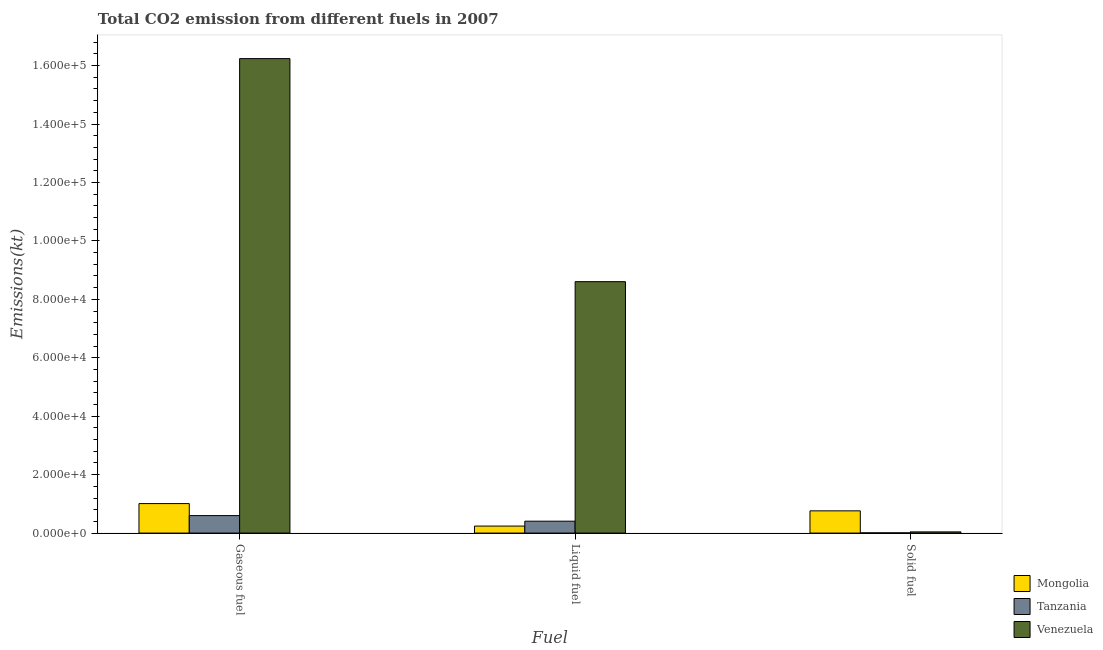How many different coloured bars are there?
Your answer should be compact. 3. How many groups of bars are there?
Offer a very short reply. 3. Are the number of bars per tick equal to the number of legend labels?
Give a very brief answer. Yes. How many bars are there on the 3rd tick from the right?
Provide a succinct answer. 3. What is the label of the 1st group of bars from the left?
Give a very brief answer. Gaseous fuel. What is the amount of co2 emissions from solid fuel in Mongolia?
Your answer should be compact. 7605.36. Across all countries, what is the maximum amount of co2 emissions from liquid fuel?
Your answer should be very brief. 8.60e+04. Across all countries, what is the minimum amount of co2 emissions from solid fuel?
Offer a very short reply. 73.34. In which country was the amount of co2 emissions from liquid fuel maximum?
Your answer should be very brief. Venezuela. In which country was the amount of co2 emissions from liquid fuel minimum?
Your response must be concise. Mongolia. What is the total amount of co2 emissions from liquid fuel in the graph?
Your answer should be very brief. 9.25e+04. What is the difference between the amount of co2 emissions from solid fuel in Tanzania and that in Venezuela?
Offer a terse response. -330.03. What is the difference between the amount of co2 emissions from liquid fuel in Mongolia and the amount of co2 emissions from gaseous fuel in Tanzania?
Offer a terse response. -3582.66. What is the average amount of co2 emissions from liquid fuel per country?
Make the answer very short. 3.08e+04. What is the difference between the amount of co2 emissions from gaseous fuel and amount of co2 emissions from liquid fuel in Venezuela?
Keep it short and to the point. 7.63e+04. In how many countries, is the amount of co2 emissions from gaseous fuel greater than 124000 kt?
Your answer should be compact. 1. What is the ratio of the amount of co2 emissions from solid fuel in Tanzania to that in Venezuela?
Offer a very short reply. 0.18. Is the amount of co2 emissions from gaseous fuel in Venezuela less than that in Tanzania?
Provide a short and direct response. No. What is the difference between the highest and the second highest amount of co2 emissions from solid fuel?
Your answer should be compact. 7201.99. What is the difference between the highest and the lowest amount of co2 emissions from solid fuel?
Keep it short and to the point. 7532.02. In how many countries, is the amount of co2 emissions from liquid fuel greater than the average amount of co2 emissions from liquid fuel taken over all countries?
Offer a terse response. 1. Is the sum of the amount of co2 emissions from gaseous fuel in Venezuela and Tanzania greater than the maximum amount of co2 emissions from solid fuel across all countries?
Ensure brevity in your answer.  Yes. What does the 1st bar from the left in Liquid fuel represents?
Provide a succinct answer. Mongolia. What does the 3rd bar from the right in Liquid fuel represents?
Offer a very short reply. Mongolia. How many bars are there?
Provide a succinct answer. 9. Are all the bars in the graph horizontal?
Keep it short and to the point. No. Are the values on the major ticks of Y-axis written in scientific E-notation?
Make the answer very short. Yes. Does the graph contain any zero values?
Provide a short and direct response. No. What is the title of the graph?
Provide a succinct answer. Total CO2 emission from different fuels in 2007. Does "Malaysia" appear as one of the legend labels in the graph?
Provide a short and direct response. No. What is the label or title of the X-axis?
Your answer should be very brief. Fuel. What is the label or title of the Y-axis?
Make the answer very short. Emissions(kt). What is the Emissions(kt) of Mongolia in Gaseous fuel?
Offer a very short reply. 1.01e+04. What is the Emissions(kt) in Tanzania in Gaseous fuel?
Offer a terse response. 5980.88. What is the Emissions(kt) in Venezuela in Gaseous fuel?
Offer a terse response. 1.62e+05. What is the Emissions(kt) of Mongolia in Liquid fuel?
Provide a succinct answer. 2398.22. What is the Emissions(kt) of Tanzania in Liquid fuel?
Give a very brief answer. 4070.37. What is the Emissions(kt) in Venezuela in Liquid fuel?
Offer a terse response. 8.60e+04. What is the Emissions(kt) of Mongolia in Solid fuel?
Your response must be concise. 7605.36. What is the Emissions(kt) of Tanzania in Solid fuel?
Keep it short and to the point. 73.34. What is the Emissions(kt) in Venezuela in Solid fuel?
Offer a very short reply. 403.37. Across all Fuel, what is the maximum Emissions(kt) of Mongolia?
Provide a short and direct response. 1.01e+04. Across all Fuel, what is the maximum Emissions(kt) in Tanzania?
Keep it short and to the point. 5980.88. Across all Fuel, what is the maximum Emissions(kt) in Venezuela?
Ensure brevity in your answer.  1.62e+05. Across all Fuel, what is the minimum Emissions(kt) in Mongolia?
Offer a terse response. 2398.22. Across all Fuel, what is the minimum Emissions(kt) in Tanzania?
Your response must be concise. 73.34. Across all Fuel, what is the minimum Emissions(kt) in Venezuela?
Your answer should be very brief. 403.37. What is the total Emissions(kt) of Mongolia in the graph?
Offer a terse response. 2.01e+04. What is the total Emissions(kt) in Tanzania in the graph?
Provide a short and direct response. 1.01e+04. What is the total Emissions(kt) of Venezuela in the graph?
Ensure brevity in your answer.  2.49e+05. What is the difference between the Emissions(kt) of Mongolia in Gaseous fuel and that in Liquid fuel?
Keep it short and to the point. 7693.37. What is the difference between the Emissions(kt) in Tanzania in Gaseous fuel and that in Liquid fuel?
Make the answer very short. 1910.51. What is the difference between the Emissions(kt) of Venezuela in Gaseous fuel and that in Liquid fuel?
Your answer should be very brief. 7.63e+04. What is the difference between the Emissions(kt) of Mongolia in Gaseous fuel and that in Solid fuel?
Ensure brevity in your answer.  2486.23. What is the difference between the Emissions(kt) in Tanzania in Gaseous fuel and that in Solid fuel?
Your response must be concise. 5907.54. What is the difference between the Emissions(kt) of Venezuela in Gaseous fuel and that in Solid fuel?
Provide a succinct answer. 1.62e+05. What is the difference between the Emissions(kt) in Mongolia in Liquid fuel and that in Solid fuel?
Ensure brevity in your answer.  -5207.14. What is the difference between the Emissions(kt) of Tanzania in Liquid fuel and that in Solid fuel?
Keep it short and to the point. 3997.03. What is the difference between the Emissions(kt) of Venezuela in Liquid fuel and that in Solid fuel?
Make the answer very short. 8.56e+04. What is the difference between the Emissions(kt) in Mongolia in Gaseous fuel and the Emissions(kt) in Tanzania in Liquid fuel?
Offer a terse response. 6021.21. What is the difference between the Emissions(kt) in Mongolia in Gaseous fuel and the Emissions(kt) in Venezuela in Liquid fuel?
Your answer should be compact. -7.60e+04. What is the difference between the Emissions(kt) in Tanzania in Gaseous fuel and the Emissions(kt) in Venezuela in Liquid fuel?
Offer a terse response. -8.01e+04. What is the difference between the Emissions(kt) of Mongolia in Gaseous fuel and the Emissions(kt) of Tanzania in Solid fuel?
Your answer should be very brief. 1.00e+04. What is the difference between the Emissions(kt) of Mongolia in Gaseous fuel and the Emissions(kt) of Venezuela in Solid fuel?
Keep it short and to the point. 9688.21. What is the difference between the Emissions(kt) of Tanzania in Gaseous fuel and the Emissions(kt) of Venezuela in Solid fuel?
Your response must be concise. 5577.51. What is the difference between the Emissions(kt) of Mongolia in Liquid fuel and the Emissions(kt) of Tanzania in Solid fuel?
Provide a succinct answer. 2324.88. What is the difference between the Emissions(kt) in Mongolia in Liquid fuel and the Emissions(kt) in Venezuela in Solid fuel?
Offer a very short reply. 1994.85. What is the difference between the Emissions(kt) of Tanzania in Liquid fuel and the Emissions(kt) of Venezuela in Solid fuel?
Your answer should be compact. 3667. What is the average Emissions(kt) in Mongolia per Fuel?
Give a very brief answer. 6698.39. What is the average Emissions(kt) of Tanzania per Fuel?
Keep it short and to the point. 3374.86. What is the average Emissions(kt) in Venezuela per Fuel?
Your response must be concise. 8.29e+04. What is the difference between the Emissions(kt) of Mongolia and Emissions(kt) of Tanzania in Gaseous fuel?
Give a very brief answer. 4110.71. What is the difference between the Emissions(kt) in Mongolia and Emissions(kt) in Venezuela in Gaseous fuel?
Ensure brevity in your answer.  -1.52e+05. What is the difference between the Emissions(kt) in Tanzania and Emissions(kt) in Venezuela in Gaseous fuel?
Keep it short and to the point. -1.56e+05. What is the difference between the Emissions(kt) of Mongolia and Emissions(kt) of Tanzania in Liquid fuel?
Provide a short and direct response. -1672.15. What is the difference between the Emissions(kt) in Mongolia and Emissions(kt) in Venezuela in Liquid fuel?
Give a very brief answer. -8.36e+04. What is the difference between the Emissions(kt) of Tanzania and Emissions(kt) of Venezuela in Liquid fuel?
Offer a terse response. -8.20e+04. What is the difference between the Emissions(kt) in Mongolia and Emissions(kt) in Tanzania in Solid fuel?
Keep it short and to the point. 7532.02. What is the difference between the Emissions(kt) in Mongolia and Emissions(kt) in Venezuela in Solid fuel?
Offer a terse response. 7201.99. What is the difference between the Emissions(kt) of Tanzania and Emissions(kt) of Venezuela in Solid fuel?
Your response must be concise. -330.03. What is the ratio of the Emissions(kt) of Mongolia in Gaseous fuel to that in Liquid fuel?
Offer a terse response. 4.21. What is the ratio of the Emissions(kt) of Tanzania in Gaseous fuel to that in Liquid fuel?
Your answer should be compact. 1.47. What is the ratio of the Emissions(kt) in Venezuela in Gaseous fuel to that in Liquid fuel?
Ensure brevity in your answer.  1.89. What is the ratio of the Emissions(kt) in Mongolia in Gaseous fuel to that in Solid fuel?
Offer a very short reply. 1.33. What is the ratio of the Emissions(kt) in Tanzania in Gaseous fuel to that in Solid fuel?
Provide a succinct answer. 81.55. What is the ratio of the Emissions(kt) in Venezuela in Gaseous fuel to that in Solid fuel?
Your response must be concise. 402.57. What is the ratio of the Emissions(kt) of Mongolia in Liquid fuel to that in Solid fuel?
Offer a terse response. 0.32. What is the ratio of the Emissions(kt) of Tanzania in Liquid fuel to that in Solid fuel?
Make the answer very short. 55.5. What is the ratio of the Emissions(kt) in Venezuela in Liquid fuel to that in Solid fuel?
Give a very brief answer. 213.31. What is the difference between the highest and the second highest Emissions(kt) of Mongolia?
Your answer should be very brief. 2486.23. What is the difference between the highest and the second highest Emissions(kt) of Tanzania?
Ensure brevity in your answer.  1910.51. What is the difference between the highest and the second highest Emissions(kt) of Venezuela?
Make the answer very short. 7.63e+04. What is the difference between the highest and the lowest Emissions(kt) of Mongolia?
Your answer should be compact. 7693.37. What is the difference between the highest and the lowest Emissions(kt) of Tanzania?
Ensure brevity in your answer.  5907.54. What is the difference between the highest and the lowest Emissions(kt) in Venezuela?
Your response must be concise. 1.62e+05. 